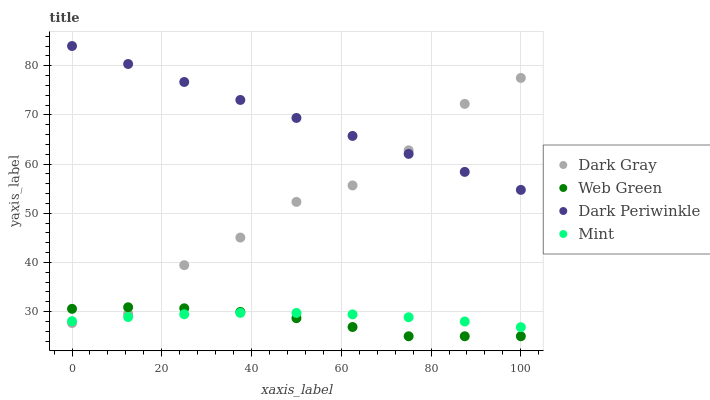Does Web Green have the minimum area under the curve?
Answer yes or no. Yes. Does Dark Periwinkle have the maximum area under the curve?
Answer yes or no. Yes. Does Mint have the minimum area under the curve?
Answer yes or no. No. Does Mint have the maximum area under the curve?
Answer yes or no. No. Is Dark Periwinkle the smoothest?
Answer yes or no. Yes. Is Dark Gray the roughest?
Answer yes or no. Yes. Is Mint the smoothest?
Answer yes or no. No. Is Mint the roughest?
Answer yes or no. No. Does Web Green have the lowest value?
Answer yes or no. Yes. Does Mint have the lowest value?
Answer yes or no. No. Does Dark Periwinkle have the highest value?
Answer yes or no. Yes. Does Mint have the highest value?
Answer yes or no. No. Is Web Green less than Dark Periwinkle?
Answer yes or no. Yes. Is Dark Periwinkle greater than Web Green?
Answer yes or no. Yes. Does Mint intersect Dark Gray?
Answer yes or no. Yes. Is Mint less than Dark Gray?
Answer yes or no. No. Is Mint greater than Dark Gray?
Answer yes or no. No. Does Web Green intersect Dark Periwinkle?
Answer yes or no. No. 